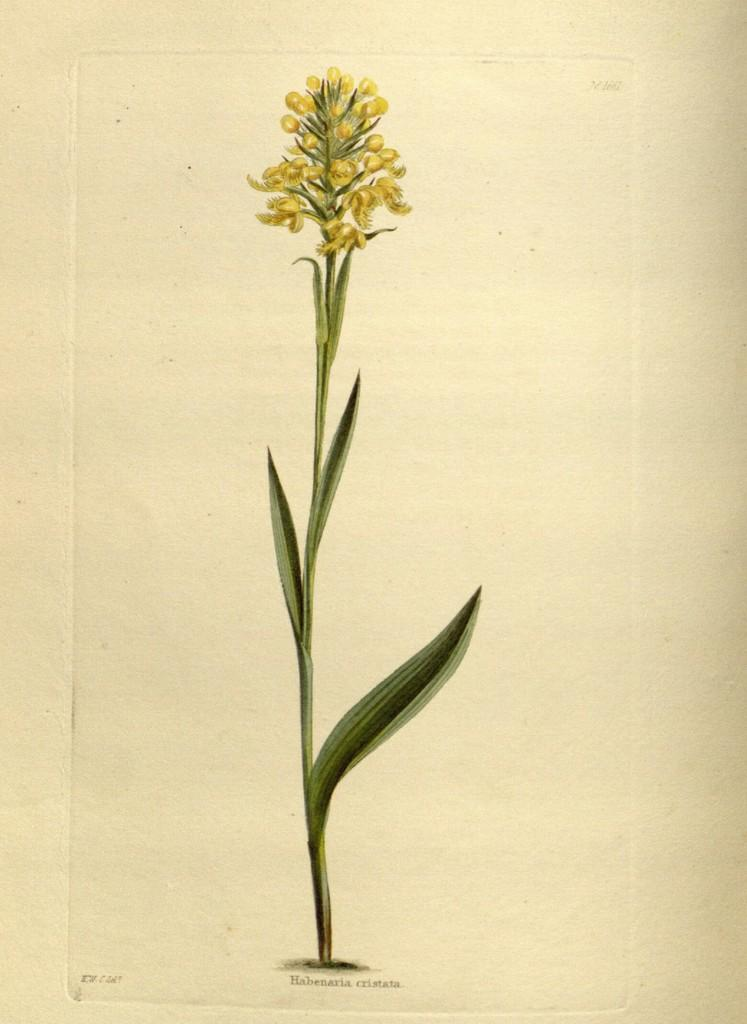What is featured on the poster in the image? The poster contains a plant with flowers and buds. What else can be seen on the poster besides the plant? There is text on the poster. Can you tell me how many balls are visible in the image? There are no balls present in the image. What type of duck can be seen swimming in the image? There is no duck present in the image. 